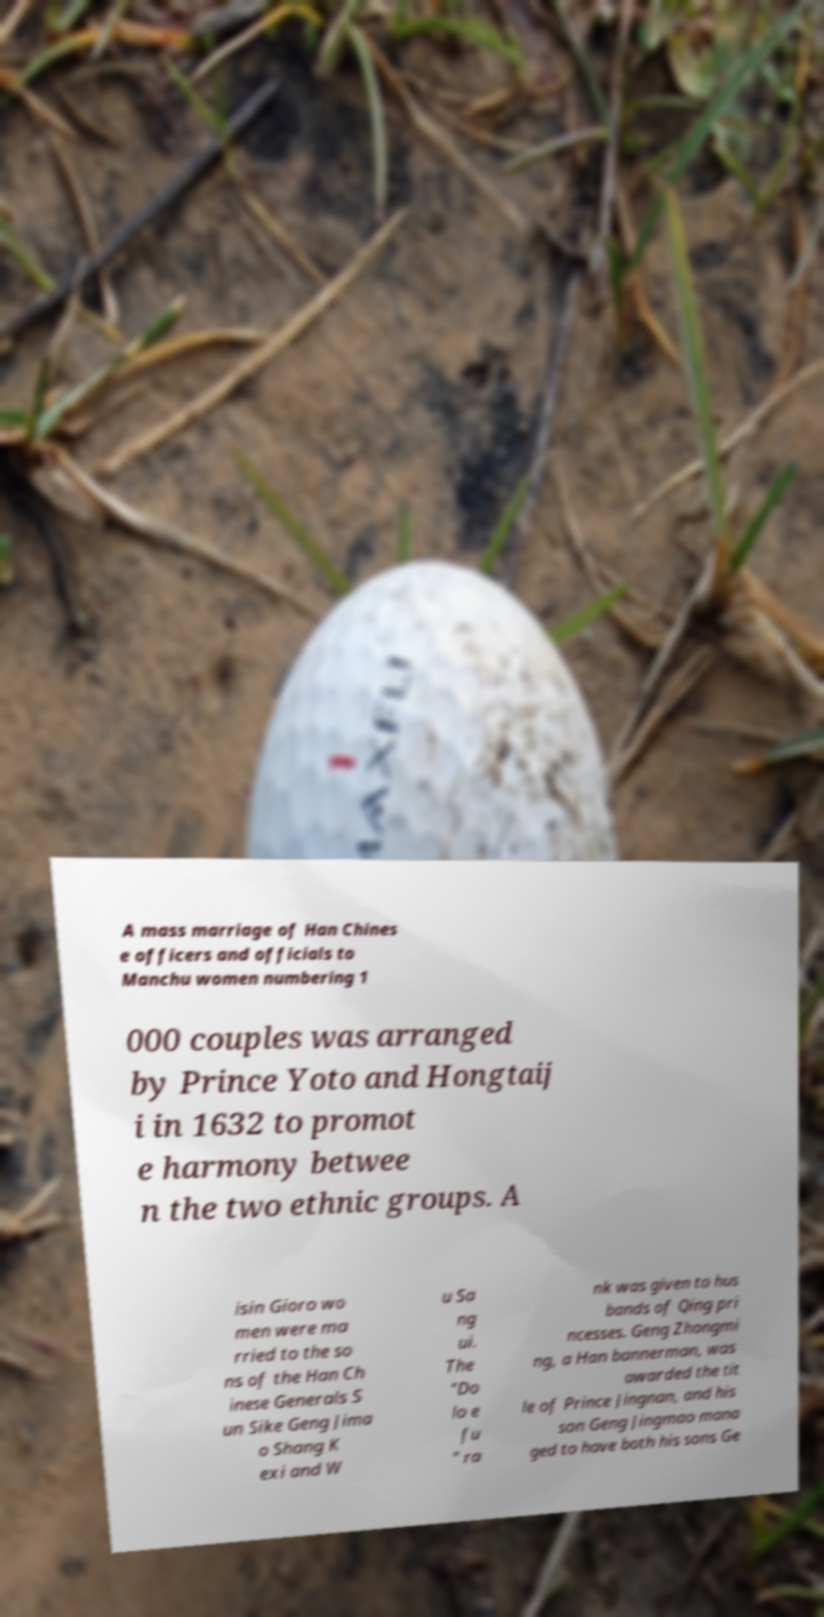I need the written content from this picture converted into text. Can you do that? A mass marriage of Han Chines e officers and officials to Manchu women numbering 1 000 couples was arranged by Prince Yoto and Hongtaij i in 1632 to promot e harmony betwee n the two ethnic groups. A isin Gioro wo men were ma rried to the so ns of the Han Ch inese Generals S un Sike Geng Jima o Shang K exi and W u Sa ng ui. The "Do lo e fu " ra nk was given to hus bands of Qing pri ncesses. Geng Zhongmi ng, a Han bannerman, was awarded the tit le of Prince Jingnan, and his son Geng Jingmao mana ged to have both his sons Ge 